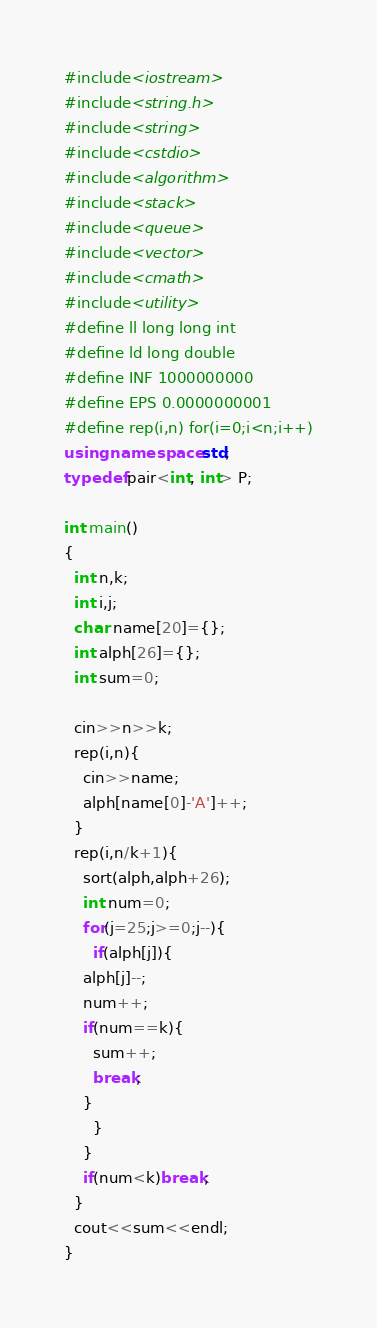<code> <loc_0><loc_0><loc_500><loc_500><_C++_>#include<iostream>
#include<string.h>
#include<string>
#include<cstdio>
#include<algorithm>
#include<stack>
#include<queue>
#include<vector>
#include<cmath>
#include<utility>
#define ll long long int
#define ld long double
#define INF 1000000000
#define EPS 0.0000000001
#define rep(i,n) for(i=0;i<n;i++)
using namespace std;
typedef pair<int, int> P;

int main()
{
  int n,k;
  int i,j;
  char name[20]={};
  int alph[26]={};
  int sum=0;

  cin>>n>>k;
  rep(i,n){
    cin>>name;
    alph[name[0]-'A']++;
  }
  rep(i,n/k+1){
    sort(alph,alph+26);
    int num=0;
    for(j=25;j>=0;j--){
      if(alph[j]){
	alph[j]--;
	num++;
	if(num==k){
	  sum++;
	  break;
	}
      }
    }
    if(num<k)break;
  }
  cout<<sum<<endl;
}
</code> 